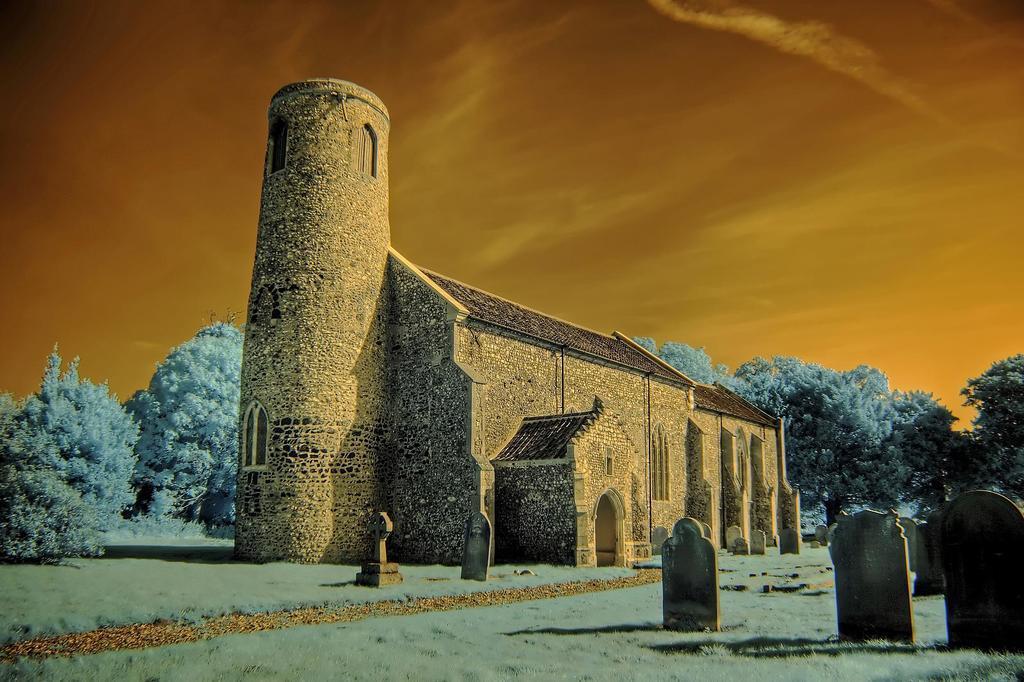In one or two sentences, can you explain what this image depicts? In this image, there is an outside view. There is a castle in the middle of the image. There are some trees on the left and on the right side of the image. There are graveyard stones in the bottom right of the image. In the background, there is a sky. 